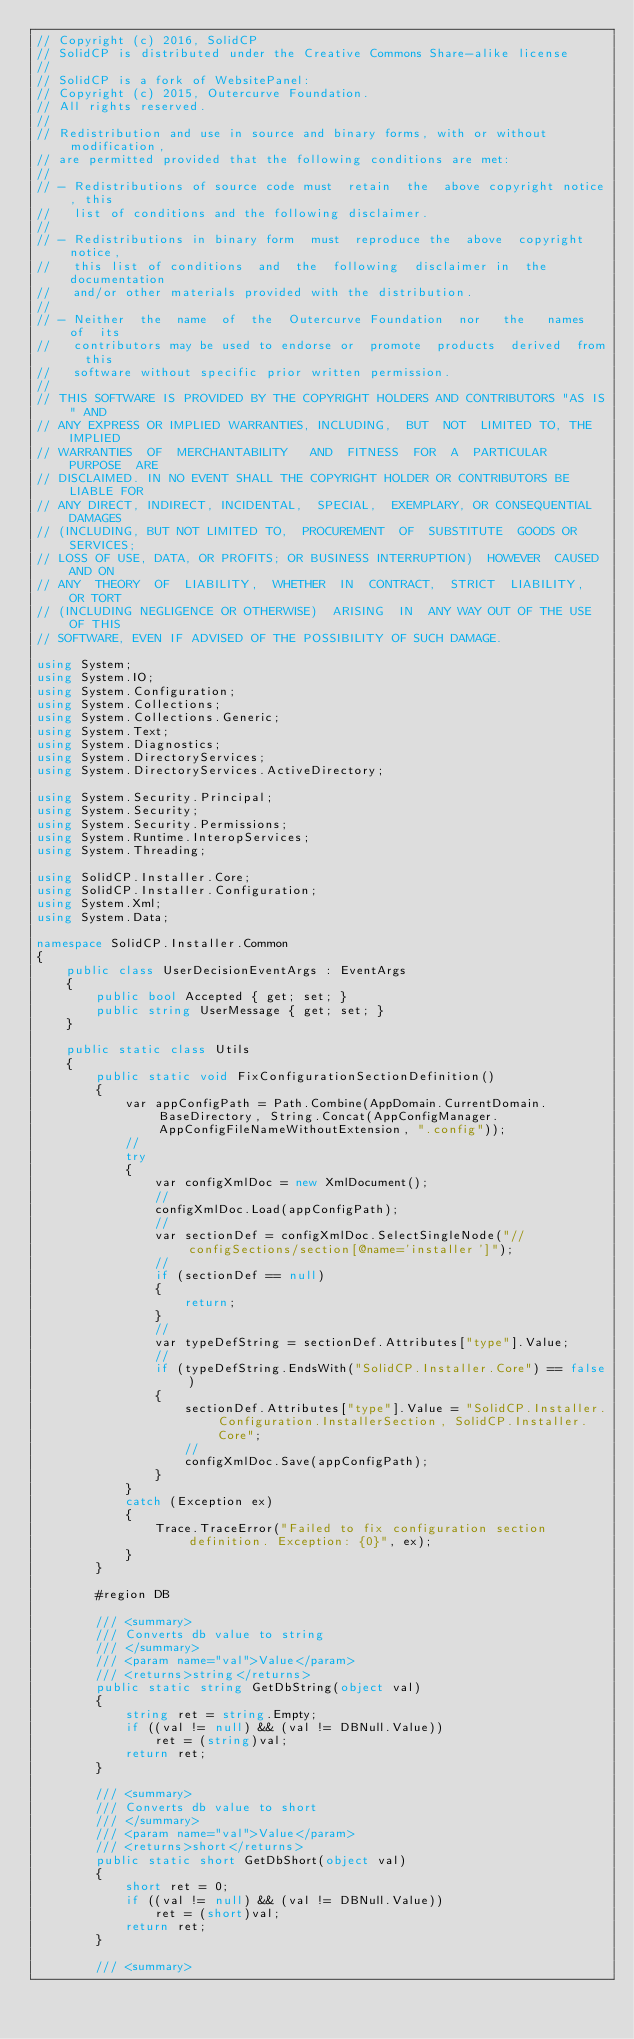<code> <loc_0><loc_0><loc_500><loc_500><_C#_>// Copyright (c) 2016, SolidCP
// SolidCP is distributed under the Creative Commons Share-alike license
// 
// SolidCP is a fork of WebsitePanel:
// Copyright (c) 2015, Outercurve Foundation.
// All rights reserved.
//
// Redistribution and use in source and binary forms, with or without modification,
// are permitted provided that the following conditions are met:
//
// - Redistributions of source code must  retain  the  above copyright notice, this
//   list of conditions and the following disclaimer.
//
// - Redistributions in binary form  must  reproduce the  above  copyright  notice,
//   this list of conditions  and  the  following  disclaimer in  the documentation
//   and/or other materials provided with the distribution.
//
// - Neither  the  name  of  the  Outercurve Foundation  nor   the   names  of  its
//   contributors may be used to endorse or  promote  products  derived  from  this
//   software without specific prior written permission.
//
// THIS SOFTWARE IS PROVIDED BY THE COPYRIGHT HOLDERS AND CONTRIBUTORS "AS IS" AND
// ANY EXPRESS OR IMPLIED WARRANTIES, INCLUDING,  BUT  NOT  LIMITED TO, THE IMPLIED
// WARRANTIES  OF  MERCHANTABILITY   AND  FITNESS  FOR  A  PARTICULAR  PURPOSE  ARE
// DISCLAIMED. IN NO EVENT SHALL THE COPYRIGHT HOLDER OR CONTRIBUTORS BE LIABLE FOR
// ANY DIRECT, INDIRECT, INCIDENTAL,  SPECIAL,  EXEMPLARY, OR CONSEQUENTIAL DAMAGES
// (INCLUDING, BUT NOT LIMITED TO,  PROCUREMENT  OF  SUBSTITUTE  GOODS OR SERVICES;
// LOSS OF USE, DATA, OR PROFITS; OR BUSINESS INTERRUPTION)  HOWEVER  CAUSED AND ON
// ANY  THEORY  OF  LIABILITY,  WHETHER  IN  CONTRACT,  STRICT  LIABILITY,  OR TORT
// (INCLUDING NEGLIGENCE OR OTHERWISE)  ARISING  IN  ANY WAY OUT OF THE USE OF THIS
// SOFTWARE, EVEN IF ADVISED OF THE POSSIBILITY OF SUCH DAMAGE.

using System;
using System.IO;
using System.Configuration;
using System.Collections;
using System.Collections.Generic;
using System.Text;
using System.Diagnostics;
using System.DirectoryServices;
using System.DirectoryServices.ActiveDirectory;

using System.Security.Principal;
using System.Security;
using System.Security.Permissions;
using System.Runtime.InteropServices;
using System.Threading;

using SolidCP.Installer.Core;
using SolidCP.Installer.Configuration;
using System.Xml;
using System.Data;

namespace SolidCP.Installer.Common
{
	public class UserDecisionEventArgs : EventArgs
	{
		public bool Accepted { get; set; }
		public string UserMessage { get; set; }
	}

	public static class Utils
	{
		public static void FixConfigurationSectionDefinition()
		{
			var appConfigPath = Path.Combine(AppDomain.CurrentDomain.BaseDirectory, String.Concat(AppConfigManager.AppConfigFileNameWithoutExtension, ".config"));
			//
			try
			{
				var configXmlDoc = new XmlDocument();
				//
				configXmlDoc.Load(appConfigPath);
				//
				var sectionDef = configXmlDoc.SelectSingleNode("//configSections/section[@name='installer']");
				//
				if (sectionDef == null)
				{
					return;
				}
				//
				var typeDefString = sectionDef.Attributes["type"].Value;
				//
				if (typeDefString.EndsWith("SolidCP.Installer.Core") == false)
				{
					sectionDef.Attributes["type"].Value = "SolidCP.Installer.Configuration.InstallerSection, SolidCP.Installer.Core";
					//
					configXmlDoc.Save(appConfigPath);
				}
			}
			catch (Exception ex)
			{
				Trace.TraceError("Failed to fix configuration section definition. Exception: {0}", ex);
			}
		}

		#region DB

		/// <summary>
		/// Converts db value to string
		/// </summary>
		/// <param name="val">Value</param>
		/// <returns>string</returns>
		public static string GetDbString(object val)
		{
			string ret = string.Empty;
			if ((val != null) && (val != DBNull.Value))
				ret = (string)val;
			return ret;
		}

		/// <summary>
		/// Converts db value to short
		/// </summary>
		/// <param name="val">Value</param>
		/// <returns>short</returns>
		public static short GetDbShort(object val)
		{
			short ret = 0;
			if ((val != null) && (val != DBNull.Value))
				ret = (short)val;
			return ret;
		}

		/// <summary></code> 